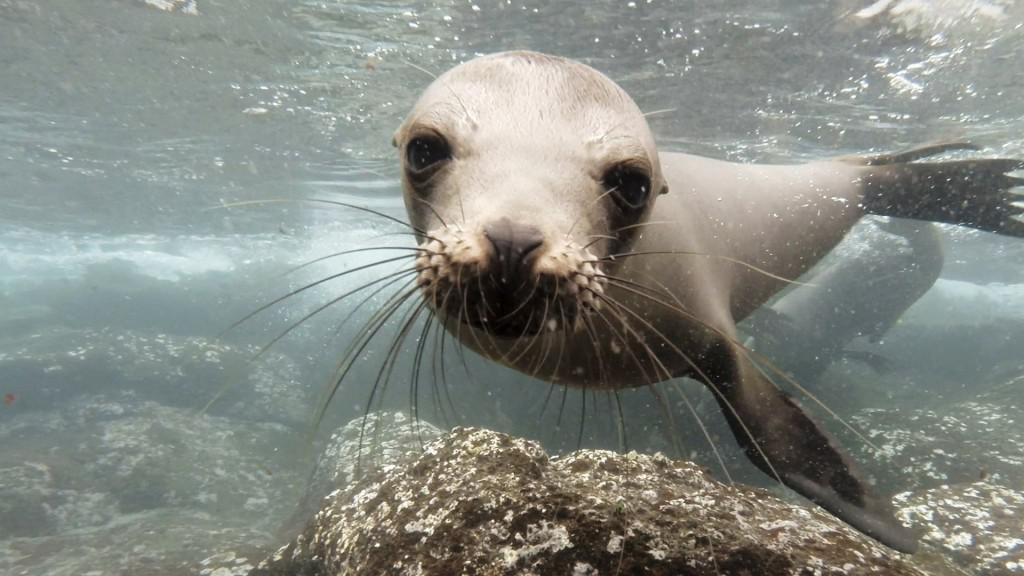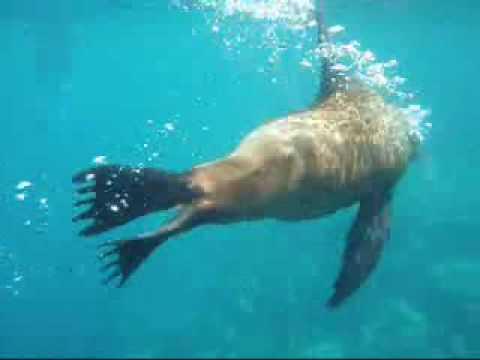The first image is the image on the left, the second image is the image on the right. Considering the images on both sides, is "One of the images shows the surface of the ocean with at least two otters popping their heads out of the water." valid? Answer yes or no. No. The first image is the image on the left, the second image is the image on the right. Considering the images on both sides, is "There are at least eight sea lions in total." valid? Answer yes or no. No. 